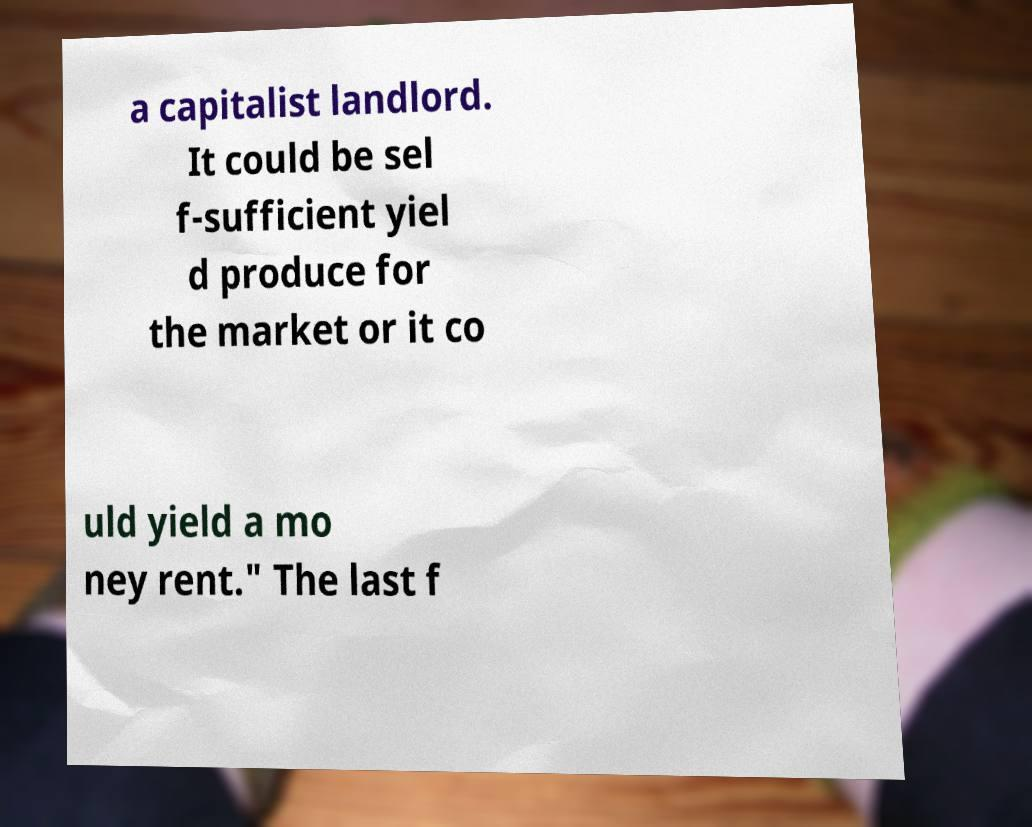I need the written content from this picture converted into text. Can you do that? a capitalist landlord. It could be sel f-sufficient yiel d produce for the market or it co uld yield a mo ney rent." The last f 